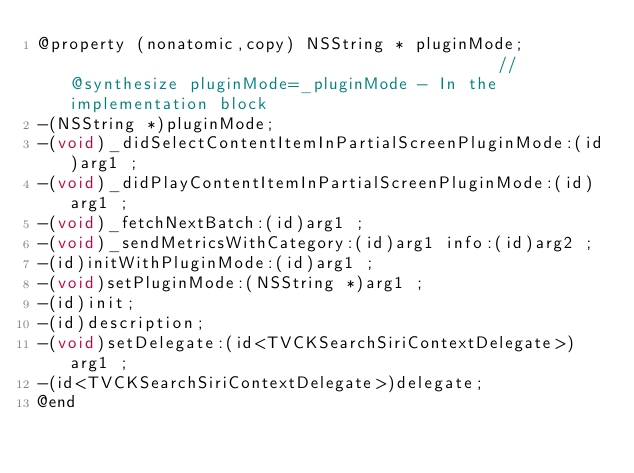Convert code to text. <code><loc_0><loc_0><loc_500><loc_500><_C_>@property (nonatomic,copy) NSString * pluginMode;                                            //@synthesize pluginMode=_pluginMode - In the implementation block
-(NSString *)pluginMode;
-(void)_didSelectContentItemInPartialScreenPluginMode:(id)arg1 ;
-(void)_didPlayContentItemInPartialScreenPluginMode:(id)arg1 ;
-(void)_fetchNextBatch:(id)arg1 ;
-(void)_sendMetricsWithCategory:(id)arg1 info:(id)arg2 ;
-(id)initWithPluginMode:(id)arg1 ;
-(void)setPluginMode:(NSString *)arg1 ;
-(id)init;
-(id)description;
-(void)setDelegate:(id<TVCKSearchSiriContextDelegate>)arg1 ;
-(id<TVCKSearchSiriContextDelegate>)delegate;
@end

</code> 